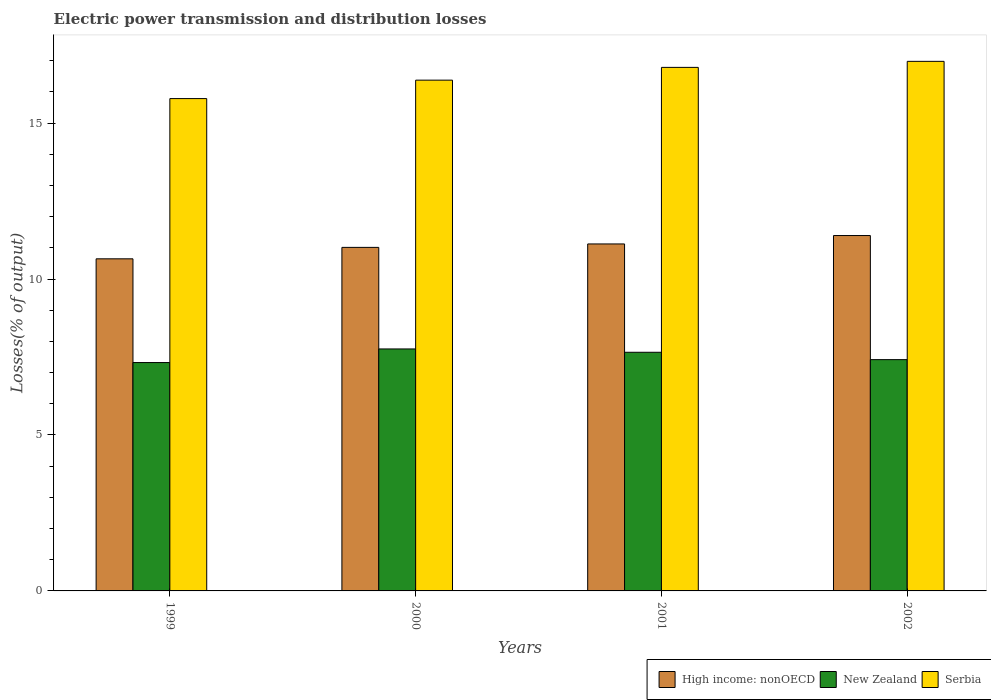Are the number of bars per tick equal to the number of legend labels?
Give a very brief answer. Yes. How many bars are there on the 1st tick from the right?
Provide a succinct answer. 3. What is the label of the 3rd group of bars from the left?
Offer a very short reply. 2001. In how many cases, is the number of bars for a given year not equal to the number of legend labels?
Your answer should be compact. 0. What is the electric power transmission and distribution losses in New Zealand in 2000?
Provide a succinct answer. 7.76. Across all years, what is the maximum electric power transmission and distribution losses in Serbia?
Keep it short and to the point. 16.98. Across all years, what is the minimum electric power transmission and distribution losses in New Zealand?
Your response must be concise. 7.32. In which year was the electric power transmission and distribution losses in New Zealand maximum?
Ensure brevity in your answer.  2000. What is the total electric power transmission and distribution losses in Serbia in the graph?
Offer a very short reply. 65.93. What is the difference between the electric power transmission and distribution losses in Serbia in 2000 and that in 2002?
Provide a short and direct response. -0.6. What is the difference between the electric power transmission and distribution losses in New Zealand in 2001 and the electric power transmission and distribution losses in Serbia in 2002?
Your response must be concise. -9.33. What is the average electric power transmission and distribution losses in Serbia per year?
Your answer should be compact. 16.48. In the year 1999, what is the difference between the electric power transmission and distribution losses in Serbia and electric power transmission and distribution losses in New Zealand?
Your response must be concise. 8.46. What is the ratio of the electric power transmission and distribution losses in High income: nonOECD in 1999 to that in 2001?
Give a very brief answer. 0.96. What is the difference between the highest and the second highest electric power transmission and distribution losses in New Zealand?
Offer a terse response. 0.11. What is the difference between the highest and the lowest electric power transmission and distribution losses in New Zealand?
Your answer should be compact. 0.44. Is the sum of the electric power transmission and distribution losses in Serbia in 1999 and 2002 greater than the maximum electric power transmission and distribution losses in High income: nonOECD across all years?
Keep it short and to the point. Yes. What does the 2nd bar from the left in 2002 represents?
Give a very brief answer. New Zealand. What does the 3rd bar from the right in 1999 represents?
Ensure brevity in your answer.  High income: nonOECD. How many bars are there?
Ensure brevity in your answer.  12. How many years are there in the graph?
Your answer should be very brief. 4. What is the difference between two consecutive major ticks on the Y-axis?
Provide a succinct answer. 5. Does the graph contain any zero values?
Your response must be concise. No. What is the title of the graph?
Your answer should be very brief. Electric power transmission and distribution losses. Does "Netherlands" appear as one of the legend labels in the graph?
Ensure brevity in your answer.  No. What is the label or title of the X-axis?
Your answer should be very brief. Years. What is the label or title of the Y-axis?
Offer a very short reply. Losses(% of output). What is the Losses(% of output) of High income: nonOECD in 1999?
Ensure brevity in your answer.  10.65. What is the Losses(% of output) of New Zealand in 1999?
Offer a very short reply. 7.32. What is the Losses(% of output) in Serbia in 1999?
Keep it short and to the point. 15.79. What is the Losses(% of output) of High income: nonOECD in 2000?
Keep it short and to the point. 11.01. What is the Losses(% of output) in New Zealand in 2000?
Your answer should be compact. 7.76. What is the Losses(% of output) of Serbia in 2000?
Ensure brevity in your answer.  16.38. What is the Losses(% of output) of High income: nonOECD in 2001?
Your answer should be very brief. 11.13. What is the Losses(% of output) of New Zealand in 2001?
Your response must be concise. 7.65. What is the Losses(% of output) in Serbia in 2001?
Your answer should be very brief. 16.79. What is the Losses(% of output) in High income: nonOECD in 2002?
Your answer should be compact. 11.39. What is the Losses(% of output) of New Zealand in 2002?
Give a very brief answer. 7.42. What is the Losses(% of output) of Serbia in 2002?
Keep it short and to the point. 16.98. Across all years, what is the maximum Losses(% of output) in High income: nonOECD?
Ensure brevity in your answer.  11.39. Across all years, what is the maximum Losses(% of output) in New Zealand?
Your answer should be compact. 7.76. Across all years, what is the maximum Losses(% of output) in Serbia?
Provide a succinct answer. 16.98. Across all years, what is the minimum Losses(% of output) in High income: nonOECD?
Give a very brief answer. 10.65. Across all years, what is the minimum Losses(% of output) in New Zealand?
Offer a very short reply. 7.32. Across all years, what is the minimum Losses(% of output) in Serbia?
Provide a succinct answer. 15.79. What is the total Losses(% of output) in High income: nonOECD in the graph?
Provide a short and direct response. 44.18. What is the total Losses(% of output) of New Zealand in the graph?
Your answer should be very brief. 30.15. What is the total Losses(% of output) of Serbia in the graph?
Provide a short and direct response. 65.93. What is the difference between the Losses(% of output) in High income: nonOECD in 1999 and that in 2000?
Keep it short and to the point. -0.37. What is the difference between the Losses(% of output) of New Zealand in 1999 and that in 2000?
Make the answer very short. -0.44. What is the difference between the Losses(% of output) of Serbia in 1999 and that in 2000?
Your response must be concise. -0.59. What is the difference between the Losses(% of output) in High income: nonOECD in 1999 and that in 2001?
Your answer should be very brief. -0.48. What is the difference between the Losses(% of output) of New Zealand in 1999 and that in 2001?
Your response must be concise. -0.33. What is the difference between the Losses(% of output) in Serbia in 1999 and that in 2001?
Your response must be concise. -1. What is the difference between the Losses(% of output) of High income: nonOECD in 1999 and that in 2002?
Offer a very short reply. -0.75. What is the difference between the Losses(% of output) of New Zealand in 1999 and that in 2002?
Provide a succinct answer. -0.09. What is the difference between the Losses(% of output) of Serbia in 1999 and that in 2002?
Provide a short and direct response. -1.19. What is the difference between the Losses(% of output) of High income: nonOECD in 2000 and that in 2001?
Ensure brevity in your answer.  -0.11. What is the difference between the Losses(% of output) of New Zealand in 2000 and that in 2001?
Keep it short and to the point. 0.11. What is the difference between the Losses(% of output) of Serbia in 2000 and that in 2001?
Your response must be concise. -0.41. What is the difference between the Losses(% of output) of High income: nonOECD in 2000 and that in 2002?
Keep it short and to the point. -0.38. What is the difference between the Losses(% of output) in New Zealand in 2000 and that in 2002?
Keep it short and to the point. 0.34. What is the difference between the Losses(% of output) of Serbia in 2000 and that in 2002?
Offer a very short reply. -0.6. What is the difference between the Losses(% of output) of High income: nonOECD in 2001 and that in 2002?
Your answer should be very brief. -0.27. What is the difference between the Losses(% of output) of New Zealand in 2001 and that in 2002?
Provide a succinct answer. 0.24. What is the difference between the Losses(% of output) of Serbia in 2001 and that in 2002?
Keep it short and to the point. -0.19. What is the difference between the Losses(% of output) of High income: nonOECD in 1999 and the Losses(% of output) of New Zealand in 2000?
Offer a very short reply. 2.89. What is the difference between the Losses(% of output) of High income: nonOECD in 1999 and the Losses(% of output) of Serbia in 2000?
Your answer should be compact. -5.73. What is the difference between the Losses(% of output) of New Zealand in 1999 and the Losses(% of output) of Serbia in 2000?
Your response must be concise. -9.05. What is the difference between the Losses(% of output) of High income: nonOECD in 1999 and the Losses(% of output) of New Zealand in 2001?
Provide a short and direct response. 3. What is the difference between the Losses(% of output) in High income: nonOECD in 1999 and the Losses(% of output) in Serbia in 2001?
Keep it short and to the point. -6.14. What is the difference between the Losses(% of output) of New Zealand in 1999 and the Losses(% of output) of Serbia in 2001?
Make the answer very short. -9.46. What is the difference between the Losses(% of output) in High income: nonOECD in 1999 and the Losses(% of output) in New Zealand in 2002?
Keep it short and to the point. 3.23. What is the difference between the Losses(% of output) in High income: nonOECD in 1999 and the Losses(% of output) in Serbia in 2002?
Offer a very short reply. -6.33. What is the difference between the Losses(% of output) in New Zealand in 1999 and the Losses(% of output) in Serbia in 2002?
Make the answer very short. -9.66. What is the difference between the Losses(% of output) in High income: nonOECD in 2000 and the Losses(% of output) in New Zealand in 2001?
Make the answer very short. 3.36. What is the difference between the Losses(% of output) of High income: nonOECD in 2000 and the Losses(% of output) of Serbia in 2001?
Give a very brief answer. -5.77. What is the difference between the Losses(% of output) of New Zealand in 2000 and the Losses(% of output) of Serbia in 2001?
Make the answer very short. -9.03. What is the difference between the Losses(% of output) of High income: nonOECD in 2000 and the Losses(% of output) of New Zealand in 2002?
Make the answer very short. 3.6. What is the difference between the Losses(% of output) in High income: nonOECD in 2000 and the Losses(% of output) in Serbia in 2002?
Ensure brevity in your answer.  -5.96. What is the difference between the Losses(% of output) in New Zealand in 2000 and the Losses(% of output) in Serbia in 2002?
Provide a short and direct response. -9.22. What is the difference between the Losses(% of output) in High income: nonOECD in 2001 and the Losses(% of output) in New Zealand in 2002?
Make the answer very short. 3.71. What is the difference between the Losses(% of output) in High income: nonOECD in 2001 and the Losses(% of output) in Serbia in 2002?
Keep it short and to the point. -5.85. What is the difference between the Losses(% of output) in New Zealand in 2001 and the Losses(% of output) in Serbia in 2002?
Your response must be concise. -9.33. What is the average Losses(% of output) of High income: nonOECD per year?
Make the answer very short. 11.05. What is the average Losses(% of output) in New Zealand per year?
Make the answer very short. 7.54. What is the average Losses(% of output) of Serbia per year?
Give a very brief answer. 16.48. In the year 1999, what is the difference between the Losses(% of output) in High income: nonOECD and Losses(% of output) in New Zealand?
Your answer should be very brief. 3.33. In the year 1999, what is the difference between the Losses(% of output) in High income: nonOECD and Losses(% of output) in Serbia?
Your answer should be compact. -5.14. In the year 1999, what is the difference between the Losses(% of output) in New Zealand and Losses(% of output) in Serbia?
Provide a short and direct response. -8.46. In the year 2000, what is the difference between the Losses(% of output) in High income: nonOECD and Losses(% of output) in New Zealand?
Offer a very short reply. 3.26. In the year 2000, what is the difference between the Losses(% of output) of High income: nonOECD and Losses(% of output) of Serbia?
Your answer should be very brief. -5.36. In the year 2000, what is the difference between the Losses(% of output) of New Zealand and Losses(% of output) of Serbia?
Keep it short and to the point. -8.62. In the year 2001, what is the difference between the Losses(% of output) in High income: nonOECD and Losses(% of output) in New Zealand?
Provide a short and direct response. 3.47. In the year 2001, what is the difference between the Losses(% of output) in High income: nonOECD and Losses(% of output) in Serbia?
Your answer should be compact. -5.66. In the year 2001, what is the difference between the Losses(% of output) of New Zealand and Losses(% of output) of Serbia?
Provide a succinct answer. -9.13. In the year 2002, what is the difference between the Losses(% of output) in High income: nonOECD and Losses(% of output) in New Zealand?
Your response must be concise. 3.98. In the year 2002, what is the difference between the Losses(% of output) in High income: nonOECD and Losses(% of output) in Serbia?
Make the answer very short. -5.58. In the year 2002, what is the difference between the Losses(% of output) in New Zealand and Losses(% of output) in Serbia?
Your response must be concise. -9.56. What is the ratio of the Losses(% of output) of High income: nonOECD in 1999 to that in 2000?
Your response must be concise. 0.97. What is the ratio of the Losses(% of output) in New Zealand in 1999 to that in 2000?
Offer a terse response. 0.94. What is the ratio of the Losses(% of output) in Serbia in 1999 to that in 2000?
Make the answer very short. 0.96. What is the ratio of the Losses(% of output) of High income: nonOECD in 1999 to that in 2001?
Make the answer very short. 0.96. What is the ratio of the Losses(% of output) in New Zealand in 1999 to that in 2001?
Your response must be concise. 0.96. What is the ratio of the Losses(% of output) of Serbia in 1999 to that in 2001?
Provide a short and direct response. 0.94. What is the ratio of the Losses(% of output) in High income: nonOECD in 1999 to that in 2002?
Offer a terse response. 0.93. What is the ratio of the Losses(% of output) in New Zealand in 1999 to that in 2002?
Your response must be concise. 0.99. What is the ratio of the Losses(% of output) in Serbia in 1999 to that in 2002?
Provide a short and direct response. 0.93. What is the ratio of the Losses(% of output) in New Zealand in 2000 to that in 2001?
Offer a terse response. 1.01. What is the ratio of the Losses(% of output) of Serbia in 2000 to that in 2001?
Your answer should be very brief. 0.98. What is the ratio of the Losses(% of output) in High income: nonOECD in 2000 to that in 2002?
Offer a terse response. 0.97. What is the ratio of the Losses(% of output) in New Zealand in 2000 to that in 2002?
Make the answer very short. 1.05. What is the ratio of the Losses(% of output) in Serbia in 2000 to that in 2002?
Provide a short and direct response. 0.96. What is the ratio of the Losses(% of output) of High income: nonOECD in 2001 to that in 2002?
Your response must be concise. 0.98. What is the ratio of the Losses(% of output) of New Zealand in 2001 to that in 2002?
Your response must be concise. 1.03. What is the ratio of the Losses(% of output) of Serbia in 2001 to that in 2002?
Make the answer very short. 0.99. What is the difference between the highest and the second highest Losses(% of output) of High income: nonOECD?
Your answer should be compact. 0.27. What is the difference between the highest and the second highest Losses(% of output) in New Zealand?
Offer a terse response. 0.11. What is the difference between the highest and the second highest Losses(% of output) in Serbia?
Your answer should be compact. 0.19. What is the difference between the highest and the lowest Losses(% of output) in High income: nonOECD?
Keep it short and to the point. 0.75. What is the difference between the highest and the lowest Losses(% of output) of New Zealand?
Make the answer very short. 0.44. What is the difference between the highest and the lowest Losses(% of output) in Serbia?
Make the answer very short. 1.19. 